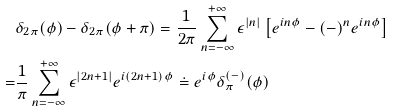<formula> <loc_0><loc_0><loc_500><loc_500>& \delta _ { 2 \pi } ( \phi ) - \delta _ { 2 \pi } ( \phi + \pi ) = \frac { 1 } { 2 \pi } \sum _ { n = - \infty } ^ { + \infty } \epsilon ^ { | n | } \left [ e ^ { i n \phi } - ( - ) ^ { n } e ^ { i n \phi } \right ] \\ = & \frac { 1 } { \pi } \sum _ { n = - \infty } ^ { + \infty } \epsilon ^ { | 2 n + 1 | } e ^ { i ( 2 n + 1 ) \phi } \doteq e ^ { i \phi } \delta _ { \pi } ^ { ( - ) } ( \phi )</formula> 